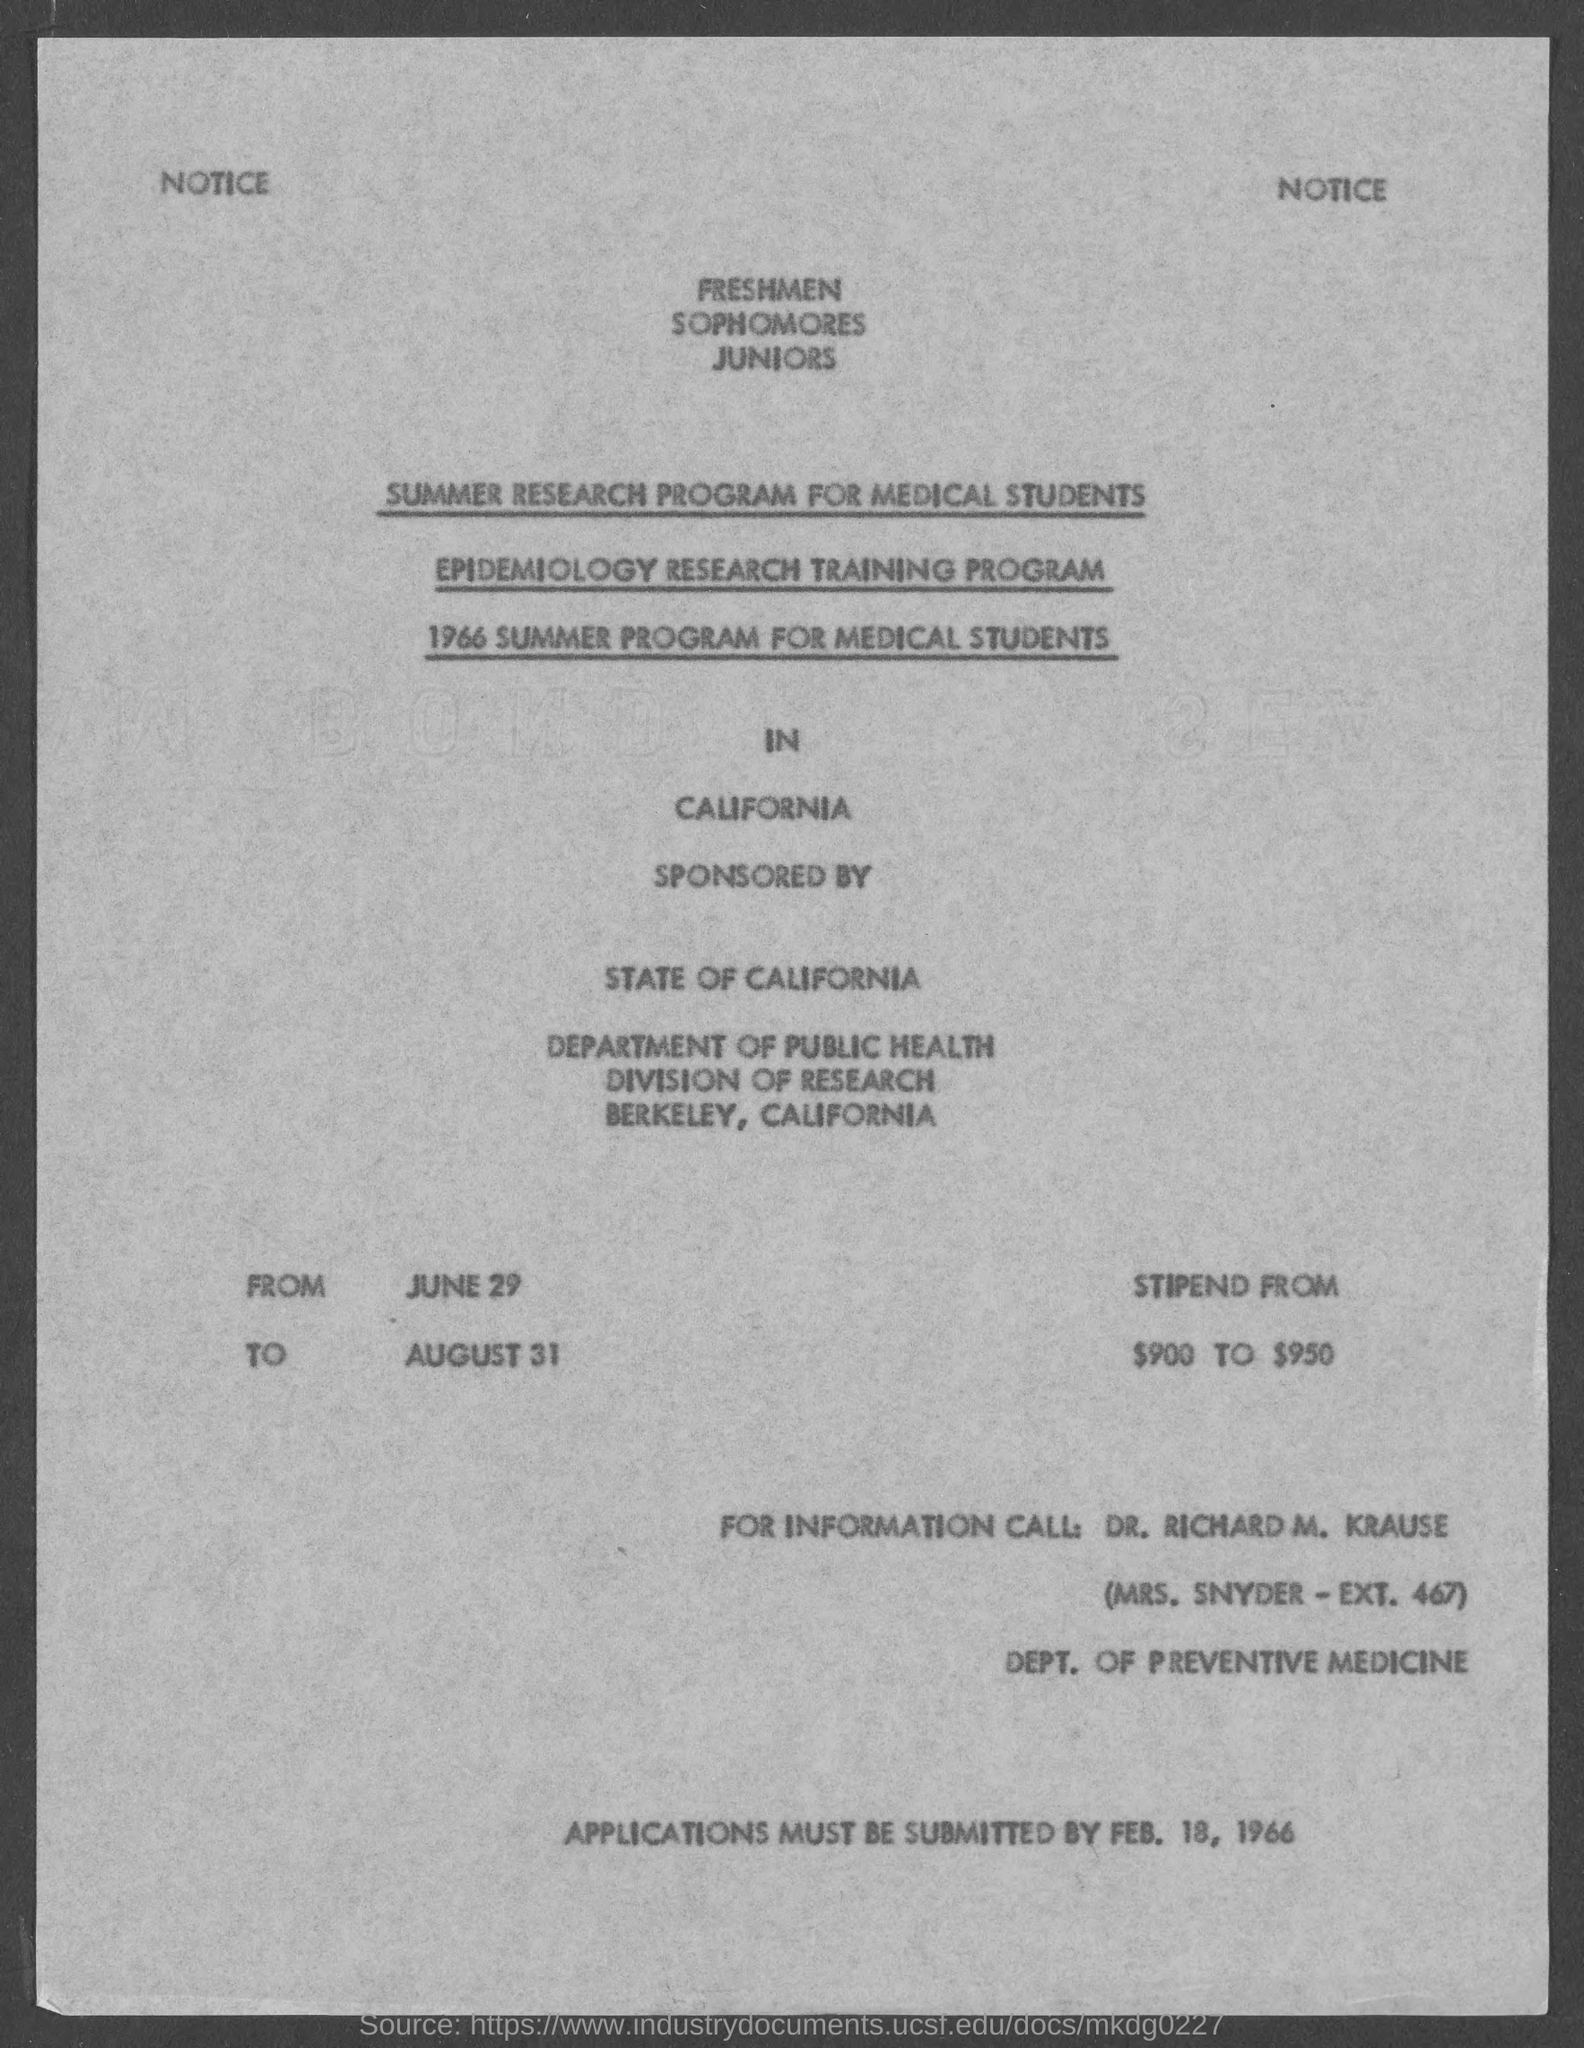Who has sponsored the programs?
Ensure brevity in your answer.  STATE OF CALIFORNIA. From when is the program?
Make the answer very short. JUNE 29. Till when is the program?
Your response must be concise. AUGUST 31. How much is the stipend from?
Keep it short and to the point. $900 TO $950. By when must the applications be submitted?
Provide a short and direct response. FEB. 18, 1966. 